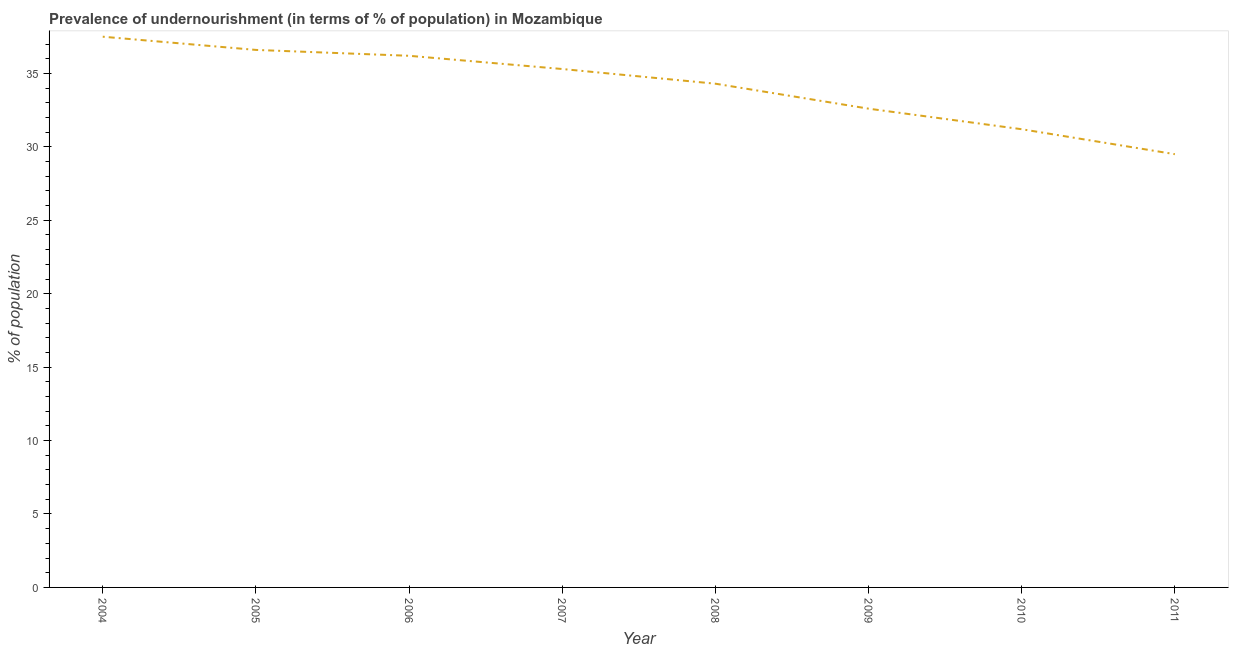What is the percentage of undernourished population in 2004?
Provide a succinct answer. 37.5. Across all years, what is the maximum percentage of undernourished population?
Provide a succinct answer. 37.5. Across all years, what is the minimum percentage of undernourished population?
Provide a short and direct response. 29.5. What is the sum of the percentage of undernourished population?
Offer a very short reply. 273.2. What is the difference between the percentage of undernourished population in 2007 and 2009?
Keep it short and to the point. 2.7. What is the average percentage of undernourished population per year?
Give a very brief answer. 34.15. What is the median percentage of undernourished population?
Offer a very short reply. 34.8. Do a majority of the years between 2009 and 2004 (inclusive) have percentage of undernourished population greater than 13 %?
Ensure brevity in your answer.  Yes. What is the ratio of the percentage of undernourished population in 2008 to that in 2009?
Provide a short and direct response. 1.05. Is the percentage of undernourished population in 2004 less than that in 2008?
Provide a succinct answer. No. What is the difference between the highest and the second highest percentage of undernourished population?
Offer a terse response. 0.9. Is the sum of the percentage of undernourished population in 2005 and 2009 greater than the maximum percentage of undernourished population across all years?
Ensure brevity in your answer.  Yes. In how many years, is the percentage of undernourished population greater than the average percentage of undernourished population taken over all years?
Offer a terse response. 5. Does the percentage of undernourished population monotonically increase over the years?
Make the answer very short. No. How many lines are there?
Your answer should be very brief. 1. How many years are there in the graph?
Give a very brief answer. 8. What is the difference between two consecutive major ticks on the Y-axis?
Provide a succinct answer. 5. Are the values on the major ticks of Y-axis written in scientific E-notation?
Offer a terse response. No. What is the title of the graph?
Keep it short and to the point. Prevalence of undernourishment (in terms of % of population) in Mozambique. What is the label or title of the Y-axis?
Offer a terse response. % of population. What is the % of population in 2004?
Your answer should be compact. 37.5. What is the % of population of 2005?
Offer a terse response. 36.6. What is the % of population in 2006?
Make the answer very short. 36.2. What is the % of population of 2007?
Offer a terse response. 35.3. What is the % of population in 2008?
Ensure brevity in your answer.  34.3. What is the % of population in 2009?
Your answer should be very brief. 32.6. What is the % of population of 2010?
Offer a terse response. 31.2. What is the % of population of 2011?
Ensure brevity in your answer.  29.5. What is the difference between the % of population in 2004 and 2005?
Ensure brevity in your answer.  0.9. What is the difference between the % of population in 2004 and 2006?
Offer a terse response. 1.3. What is the difference between the % of population in 2004 and 2008?
Provide a succinct answer. 3.2. What is the difference between the % of population in 2004 and 2009?
Your answer should be very brief. 4.9. What is the difference between the % of population in 2004 and 2010?
Your answer should be very brief. 6.3. What is the difference between the % of population in 2004 and 2011?
Your answer should be very brief. 8. What is the difference between the % of population in 2005 and 2007?
Keep it short and to the point. 1.3. What is the difference between the % of population in 2005 and 2009?
Keep it short and to the point. 4. What is the difference between the % of population in 2005 and 2010?
Provide a succinct answer. 5.4. What is the difference between the % of population in 2005 and 2011?
Provide a succinct answer. 7.1. What is the difference between the % of population in 2006 and 2008?
Give a very brief answer. 1.9. What is the difference between the % of population in 2006 and 2009?
Make the answer very short. 3.6. What is the difference between the % of population in 2006 and 2010?
Your response must be concise. 5. What is the difference between the % of population in 2007 and 2010?
Keep it short and to the point. 4.1. What is the difference between the % of population in 2009 and 2011?
Your answer should be compact. 3.1. What is the difference between the % of population in 2010 and 2011?
Provide a short and direct response. 1.7. What is the ratio of the % of population in 2004 to that in 2006?
Offer a very short reply. 1.04. What is the ratio of the % of population in 2004 to that in 2007?
Provide a short and direct response. 1.06. What is the ratio of the % of population in 2004 to that in 2008?
Provide a short and direct response. 1.09. What is the ratio of the % of population in 2004 to that in 2009?
Ensure brevity in your answer.  1.15. What is the ratio of the % of population in 2004 to that in 2010?
Your answer should be very brief. 1.2. What is the ratio of the % of population in 2004 to that in 2011?
Give a very brief answer. 1.27. What is the ratio of the % of population in 2005 to that in 2006?
Your answer should be very brief. 1.01. What is the ratio of the % of population in 2005 to that in 2008?
Keep it short and to the point. 1.07. What is the ratio of the % of population in 2005 to that in 2009?
Offer a terse response. 1.12. What is the ratio of the % of population in 2005 to that in 2010?
Provide a succinct answer. 1.17. What is the ratio of the % of population in 2005 to that in 2011?
Keep it short and to the point. 1.24. What is the ratio of the % of population in 2006 to that in 2008?
Offer a terse response. 1.05. What is the ratio of the % of population in 2006 to that in 2009?
Your response must be concise. 1.11. What is the ratio of the % of population in 2006 to that in 2010?
Provide a succinct answer. 1.16. What is the ratio of the % of population in 2006 to that in 2011?
Ensure brevity in your answer.  1.23. What is the ratio of the % of population in 2007 to that in 2009?
Keep it short and to the point. 1.08. What is the ratio of the % of population in 2007 to that in 2010?
Make the answer very short. 1.13. What is the ratio of the % of population in 2007 to that in 2011?
Keep it short and to the point. 1.2. What is the ratio of the % of population in 2008 to that in 2009?
Make the answer very short. 1.05. What is the ratio of the % of population in 2008 to that in 2010?
Your answer should be compact. 1.1. What is the ratio of the % of population in 2008 to that in 2011?
Make the answer very short. 1.16. What is the ratio of the % of population in 2009 to that in 2010?
Offer a terse response. 1.04. What is the ratio of the % of population in 2009 to that in 2011?
Your response must be concise. 1.1. What is the ratio of the % of population in 2010 to that in 2011?
Make the answer very short. 1.06. 